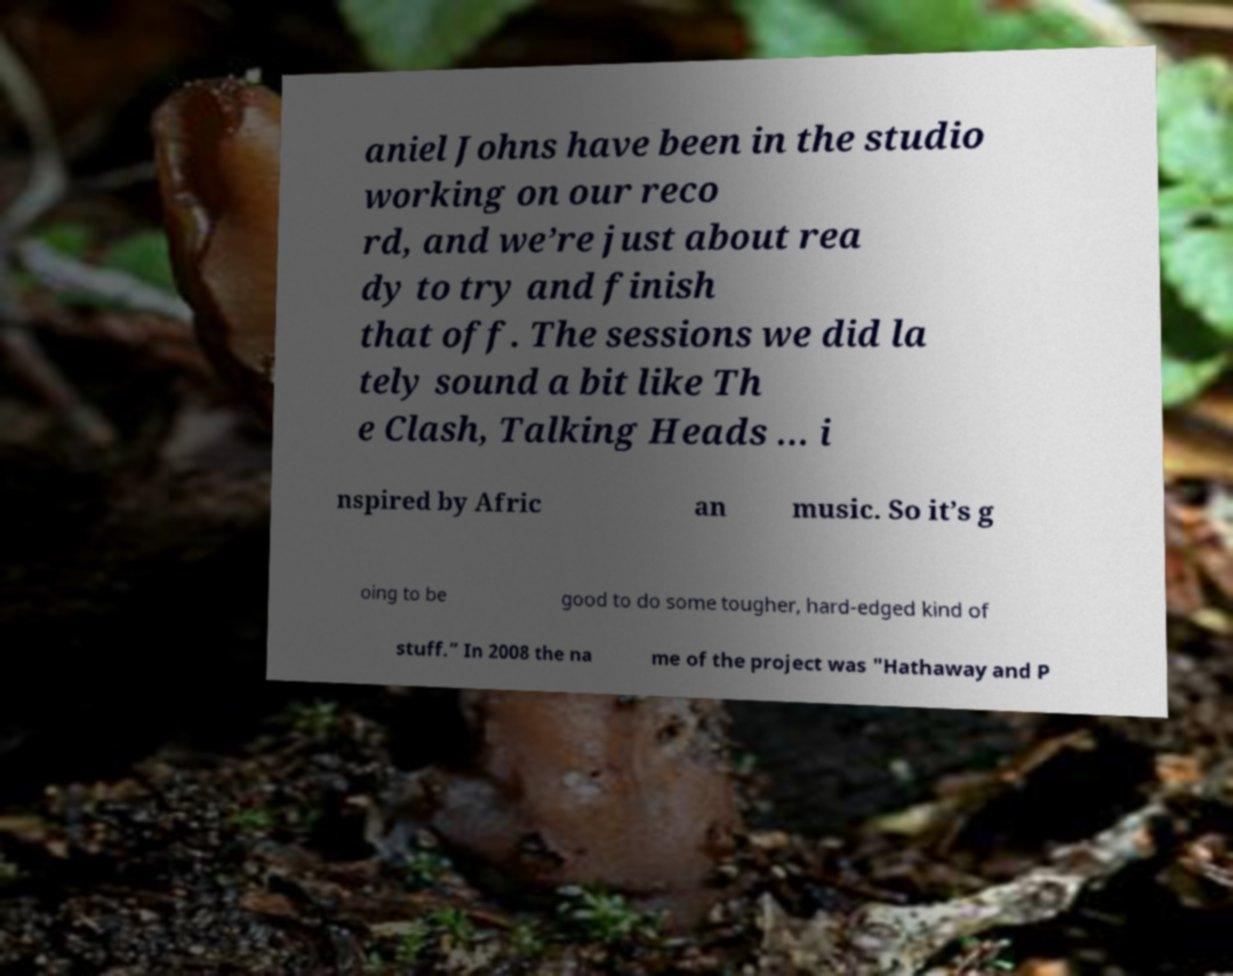Can you accurately transcribe the text from the provided image for me? aniel Johns have been in the studio working on our reco rd, and we’re just about rea dy to try and finish that off. The sessions we did la tely sound a bit like Th e Clash, Talking Heads … i nspired by Afric an music. So it’s g oing to be good to do some tougher, hard-edged kind of stuff.” In 2008 the na me of the project was "Hathaway and P 